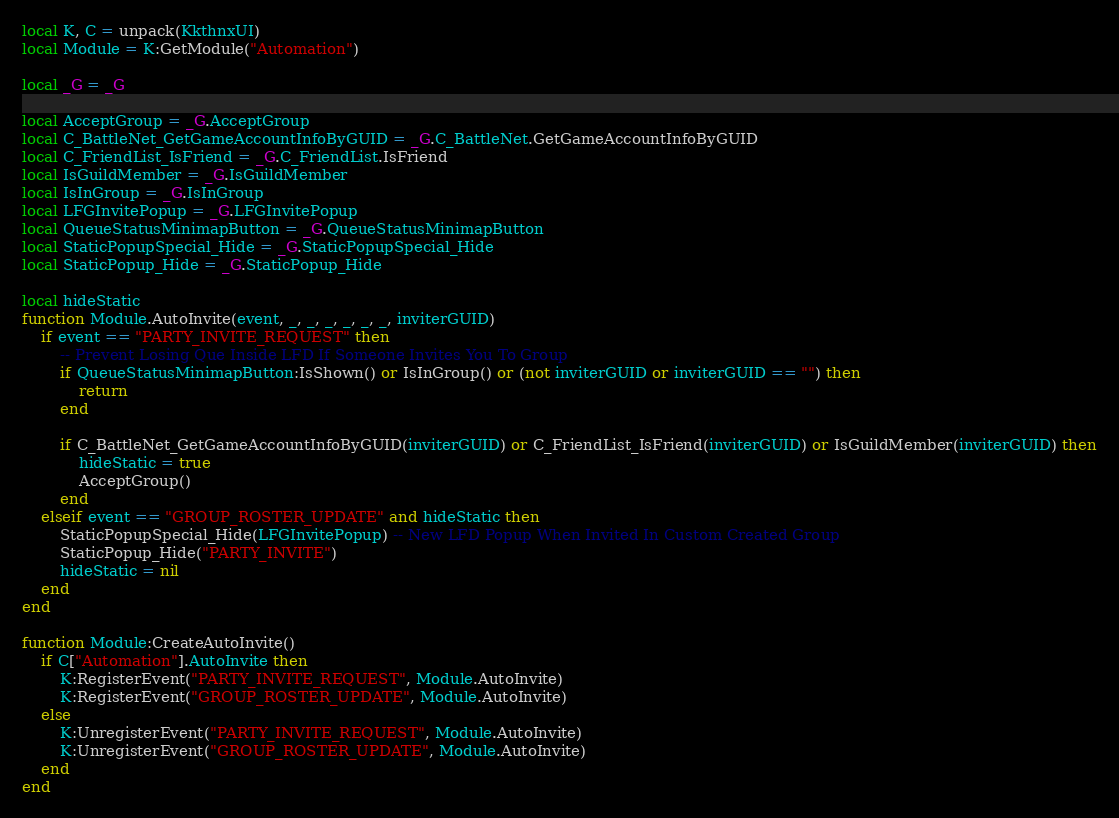Convert code to text. <code><loc_0><loc_0><loc_500><loc_500><_Lua_>local K, C = unpack(KkthnxUI)
local Module = K:GetModule("Automation")

local _G = _G

local AcceptGroup = _G.AcceptGroup
local C_BattleNet_GetGameAccountInfoByGUID = _G.C_BattleNet.GetGameAccountInfoByGUID
local C_FriendList_IsFriend = _G.C_FriendList.IsFriend
local IsGuildMember = _G.IsGuildMember
local IsInGroup = _G.IsInGroup
local LFGInvitePopup = _G.LFGInvitePopup
local QueueStatusMinimapButton = _G.QueueStatusMinimapButton
local StaticPopupSpecial_Hide = _G.StaticPopupSpecial_Hide
local StaticPopup_Hide = _G.StaticPopup_Hide

local hideStatic
function Module.AutoInvite(event, _, _, _, _, _, _, inviterGUID)
	if event == "PARTY_INVITE_REQUEST" then
		-- Prevent Losing Que Inside LFD If Someone Invites You To Group
		if QueueStatusMinimapButton:IsShown() or IsInGroup() or (not inviterGUID or inviterGUID == "") then
			return
		end

		if C_BattleNet_GetGameAccountInfoByGUID(inviterGUID) or C_FriendList_IsFriend(inviterGUID) or IsGuildMember(inviterGUID) then
			hideStatic = true
			AcceptGroup()
		end
	elseif event == "GROUP_ROSTER_UPDATE" and hideStatic then
		StaticPopupSpecial_Hide(LFGInvitePopup) -- New LFD Popup When Invited In Custom Created Group
		StaticPopup_Hide("PARTY_INVITE")
		hideStatic = nil
	end
end

function Module:CreateAutoInvite()
	if C["Automation"].AutoInvite then
		K:RegisterEvent("PARTY_INVITE_REQUEST", Module.AutoInvite)
		K:RegisterEvent("GROUP_ROSTER_UPDATE", Module.AutoInvite)
	else
		K:UnregisterEvent("PARTY_INVITE_REQUEST", Module.AutoInvite)
		K:UnregisterEvent("GROUP_ROSTER_UPDATE", Module.AutoInvite)
	end
end
</code> 